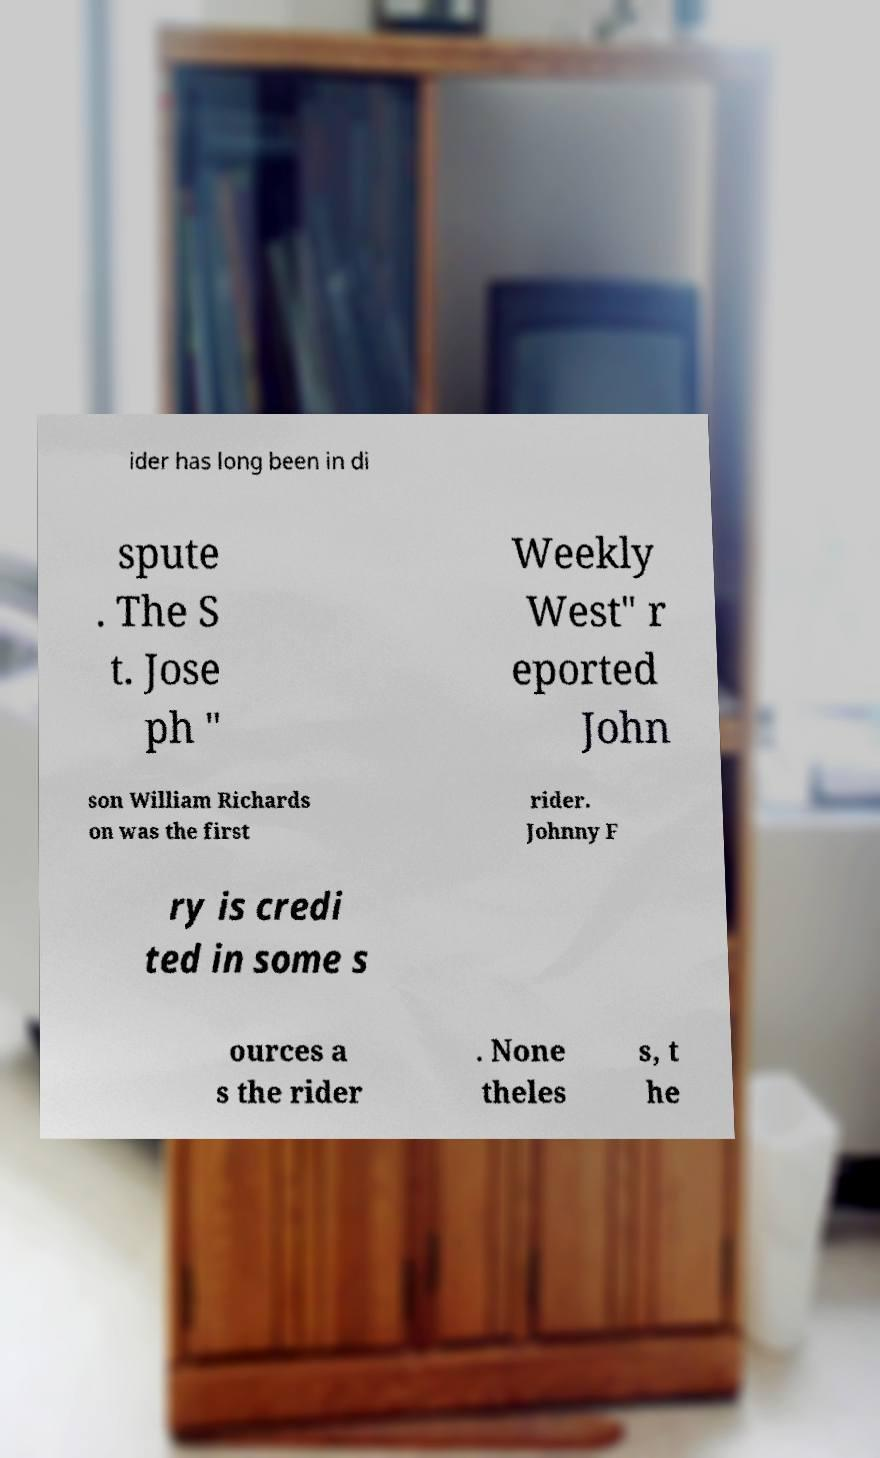For documentation purposes, I need the text within this image transcribed. Could you provide that? ider has long been in di spute . The S t. Jose ph " Weekly West" r eported John son William Richards on was the first rider. Johnny F ry is credi ted in some s ources a s the rider . None theles s, t he 